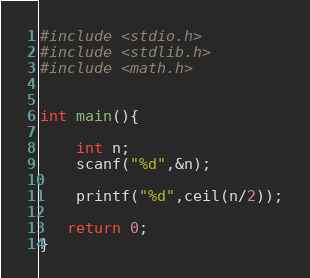Convert code to text. <code><loc_0><loc_0><loc_500><loc_500><_C_>#include <stdio.h>
#include <stdlib.h>
#include <math.h>


int main(){

    int n;
    scanf("%d",&n);

    printf("%d",ceil(n/2));

   return 0;
}
</code> 